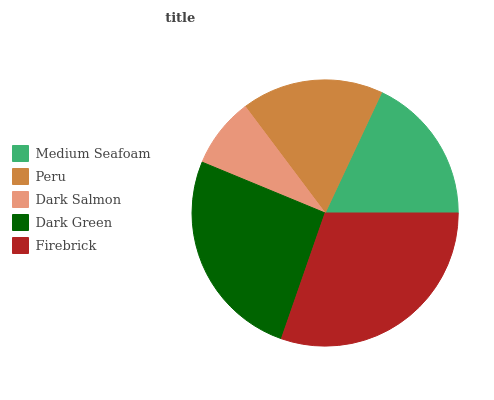Is Dark Salmon the minimum?
Answer yes or no. Yes. Is Firebrick the maximum?
Answer yes or no. Yes. Is Peru the minimum?
Answer yes or no. No. Is Peru the maximum?
Answer yes or no. No. Is Medium Seafoam greater than Peru?
Answer yes or no. Yes. Is Peru less than Medium Seafoam?
Answer yes or no. Yes. Is Peru greater than Medium Seafoam?
Answer yes or no. No. Is Medium Seafoam less than Peru?
Answer yes or no. No. Is Medium Seafoam the high median?
Answer yes or no. Yes. Is Medium Seafoam the low median?
Answer yes or no. Yes. Is Firebrick the high median?
Answer yes or no. No. Is Firebrick the low median?
Answer yes or no. No. 